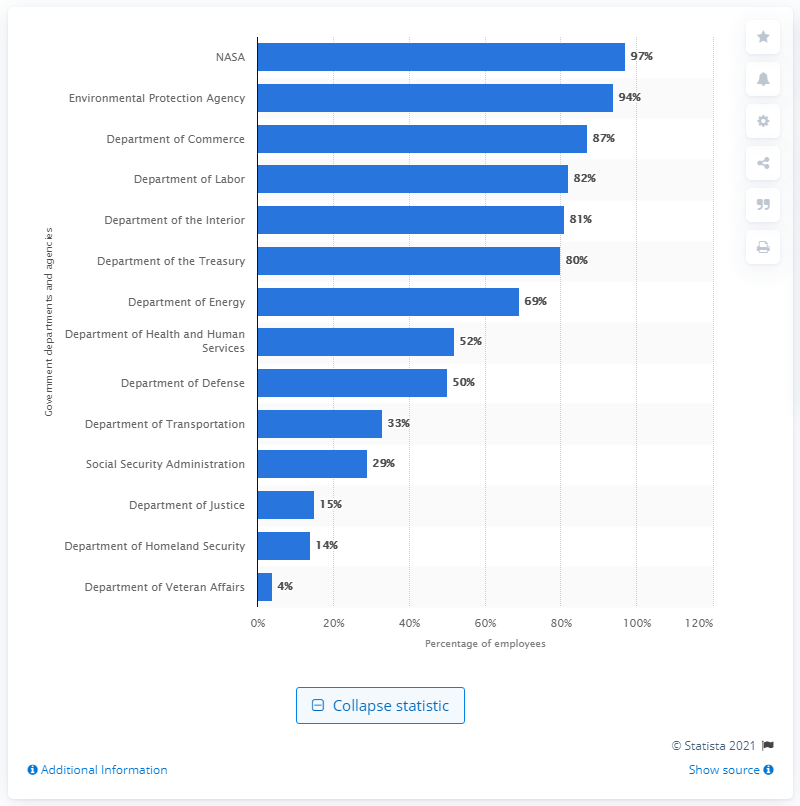Outline some significant characteristics in this image. A significant percentage of NASA employees will be furloughed as a result of the COVID-19 pandemic. 